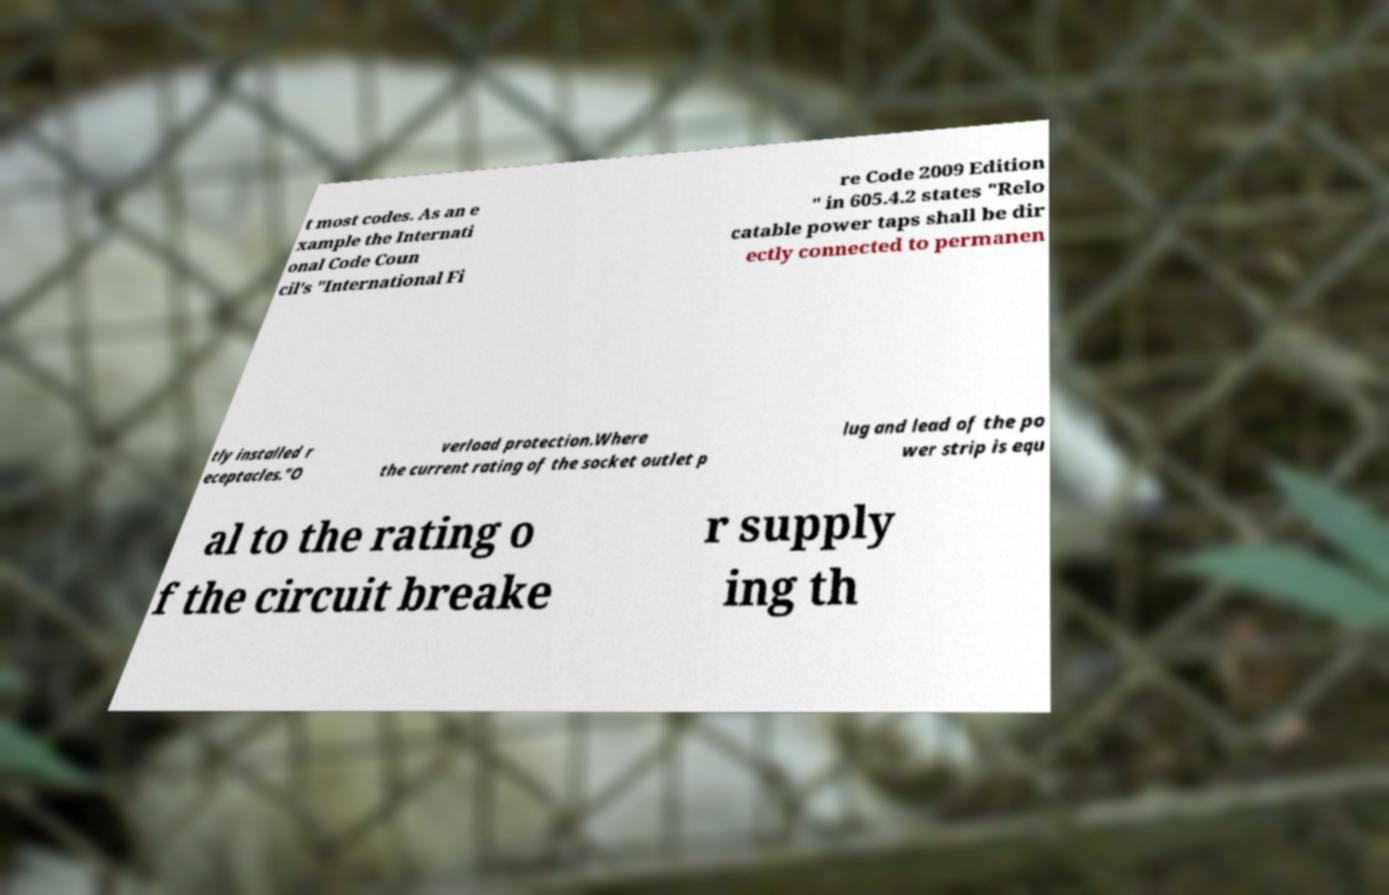I need the written content from this picture converted into text. Can you do that? t most codes. As an e xample the Internati onal Code Coun cil's "International Fi re Code 2009 Edition " in 605.4.2 states "Relo catable power taps shall be dir ectly connected to permanen tly installed r eceptacles."O verload protection.Where the current rating of the socket outlet p lug and lead of the po wer strip is equ al to the rating o f the circuit breake r supply ing th 